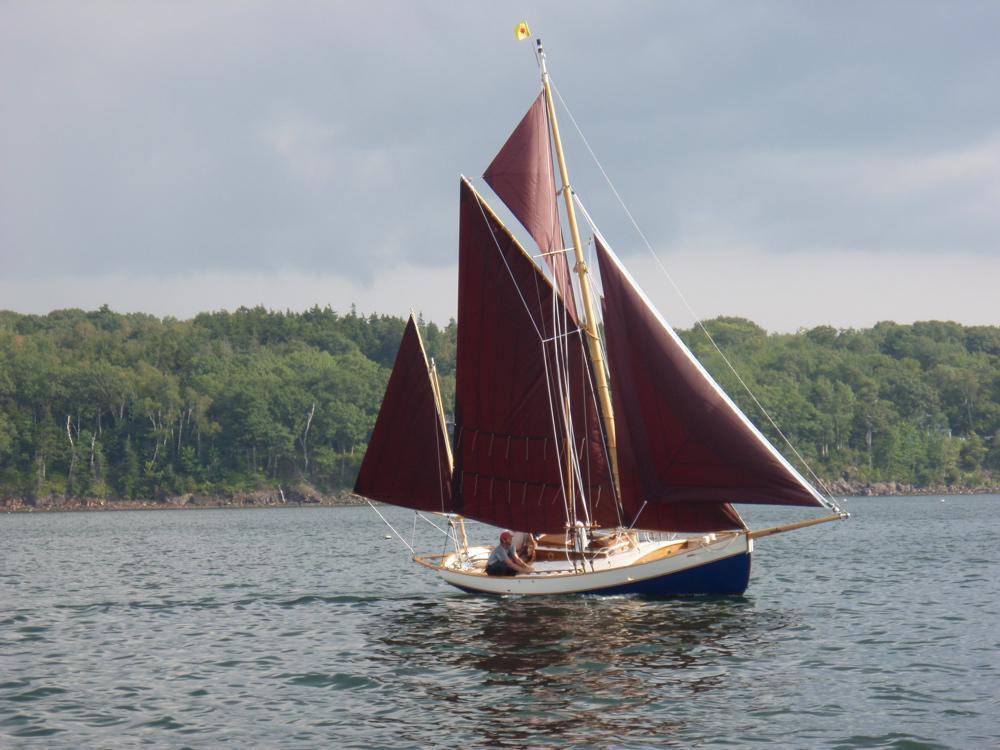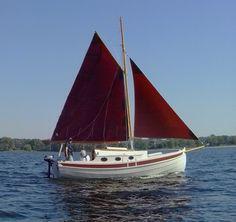The first image is the image on the left, the second image is the image on the right. For the images displayed, is the sentence "An image shows a white-bodied boat with only reddish sails." factually correct? Answer yes or no. Yes. The first image is the image on the left, the second image is the image on the right. Analyze the images presented: Is the assertion "The sails on both boats are nearly the same color." valid? Answer yes or no. Yes. 